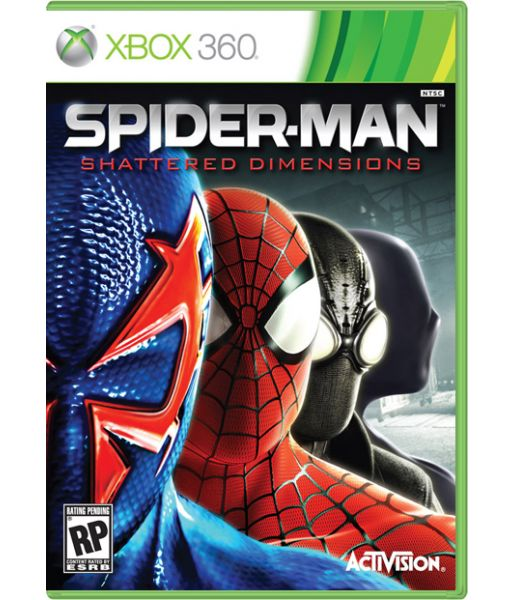Considering the design elements and the title on the game cover, what narrative or gameplay theme could be inferred about the game's content and how does the split character design contribute to that inference? The narrative or gameplay theme suggested by the design elements and the title 'Spider-Man: Shattered Dimensions' indicates a storyline or gameplay mechanic that involves navigating through multiple universes or dimensions. The split character design, displaying different versions of Spider-Man, signifies that the character will traverse through these various dimensions, each with its own unique challenges and aesthetics. This design emphasizes the core essence of Spider-Man while showcasing the diversity of powers, enemies, and environments he will encounter. The title 'Shattered Dimensions' combined with these visual cues suggests that the game's content revolves around repairing or exploring these fragmented realities, each adding a distinct layer to the overall narrative and gameplay experience. 